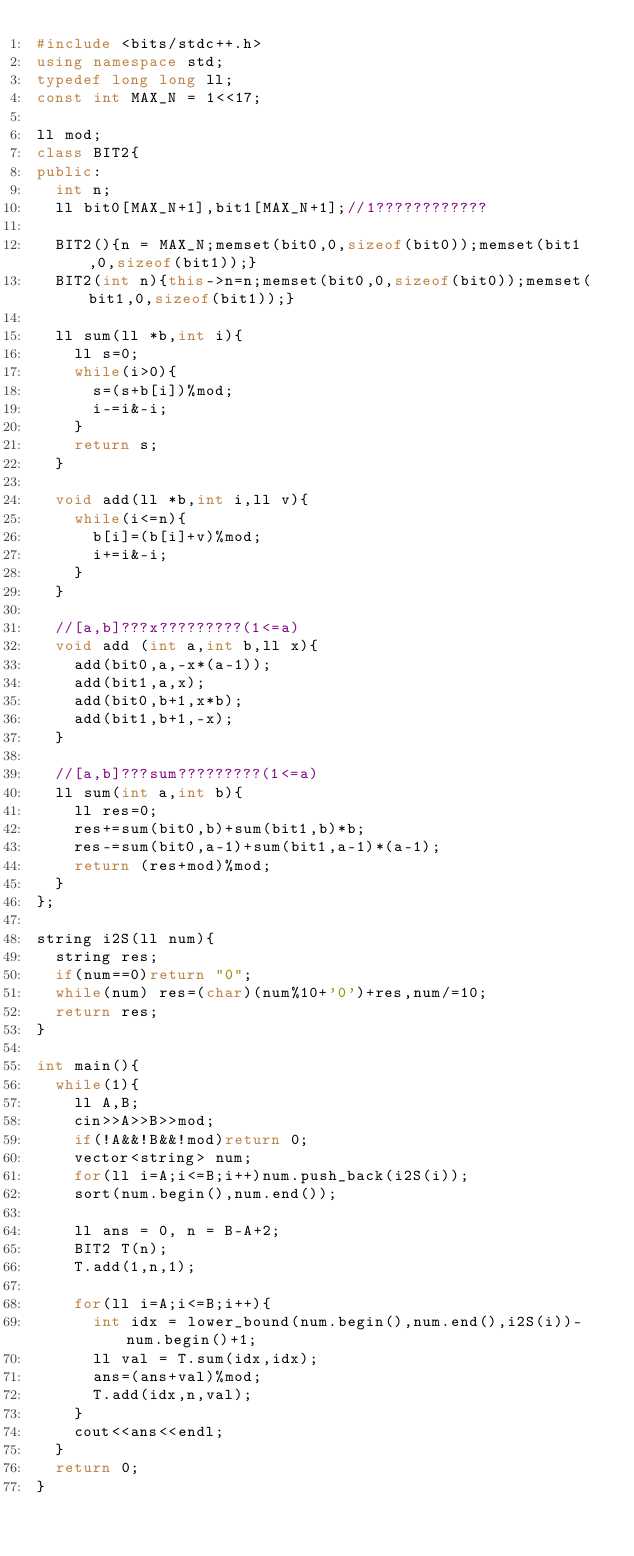<code> <loc_0><loc_0><loc_500><loc_500><_C++_>#include <bits/stdc++.h>
using namespace std;
typedef long long ll;
const int MAX_N = 1<<17;

ll mod;
class BIT2{
public:
  int n;
  ll bit0[MAX_N+1],bit1[MAX_N+1];//1????????????

  BIT2(){n = MAX_N;memset(bit0,0,sizeof(bit0));memset(bit1,0,sizeof(bit1));}
  BIT2(int n){this->n=n;memset(bit0,0,sizeof(bit0));memset(bit1,0,sizeof(bit1));}
  
  ll sum(ll *b,int i){
    ll s=0;
    while(i>0){
      s=(s+b[i])%mod;
      i-=i&-i;
    }
    return s;
  }

  void add(ll *b,int i,ll v){
    while(i<=n){
      b[i]=(b[i]+v)%mod;
      i+=i&-i;
    }
  }

  //[a,b]???x?????????(1<=a)
  void add (int a,int b,ll x){
    add(bit0,a,-x*(a-1));
    add(bit1,a,x);
    add(bit0,b+1,x*b);
    add(bit1,b+1,-x);
  }

  //[a,b]???sum?????????(1<=a)
  ll sum(int a,int b){
    ll res=0;
    res+=sum(bit0,b)+sum(bit1,b)*b;
    res-=sum(bit0,a-1)+sum(bit1,a-1)*(a-1);
    return (res+mod)%mod;    
  }
};

string i2S(ll num){
  string res;
  if(num==0)return "0";
  while(num) res=(char)(num%10+'0')+res,num/=10;
  return res;
}

int main(){
  while(1){
    ll A,B;
    cin>>A>>B>>mod;
    if(!A&&!B&&!mod)return 0;
    vector<string> num;
    for(ll i=A;i<=B;i++)num.push_back(i2S(i));
    sort(num.begin(),num.end());
  
    ll ans = 0, n = B-A+2;
    BIT2 T(n);
    T.add(1,n,1);
    
    for(ll i=A;i<=B;i++){
      int idx = lower_bound(num.begin(),num.end(),i2S(i))-num.begin()+1;
      ll val = T.sum(idx,idx);
      ans=(ans+val)%mod;
      T.add(idx,n,val);
    }
    cout<<ans<<endl;
  }
  return 0;
}</code> 